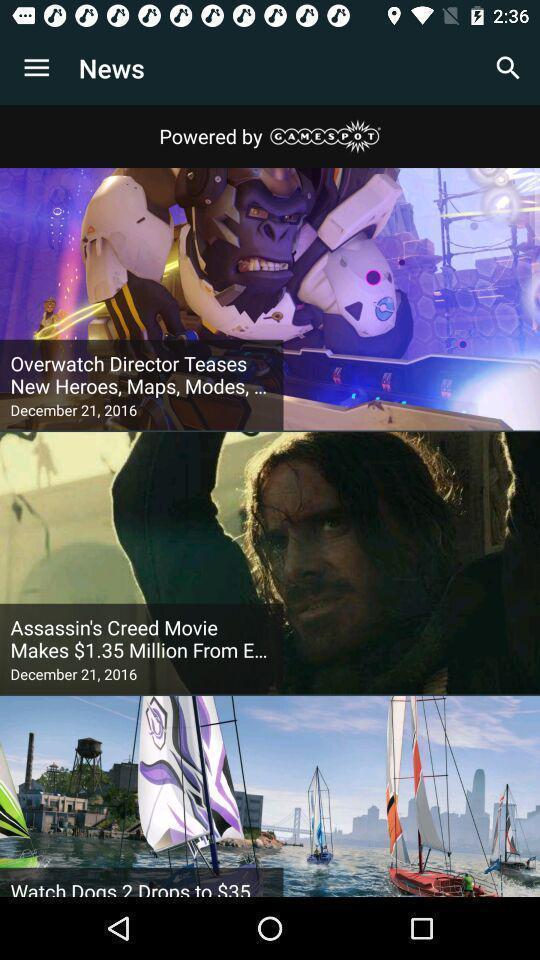Tell me what you see in this picture. Screen shows list of options in entertainment app. 